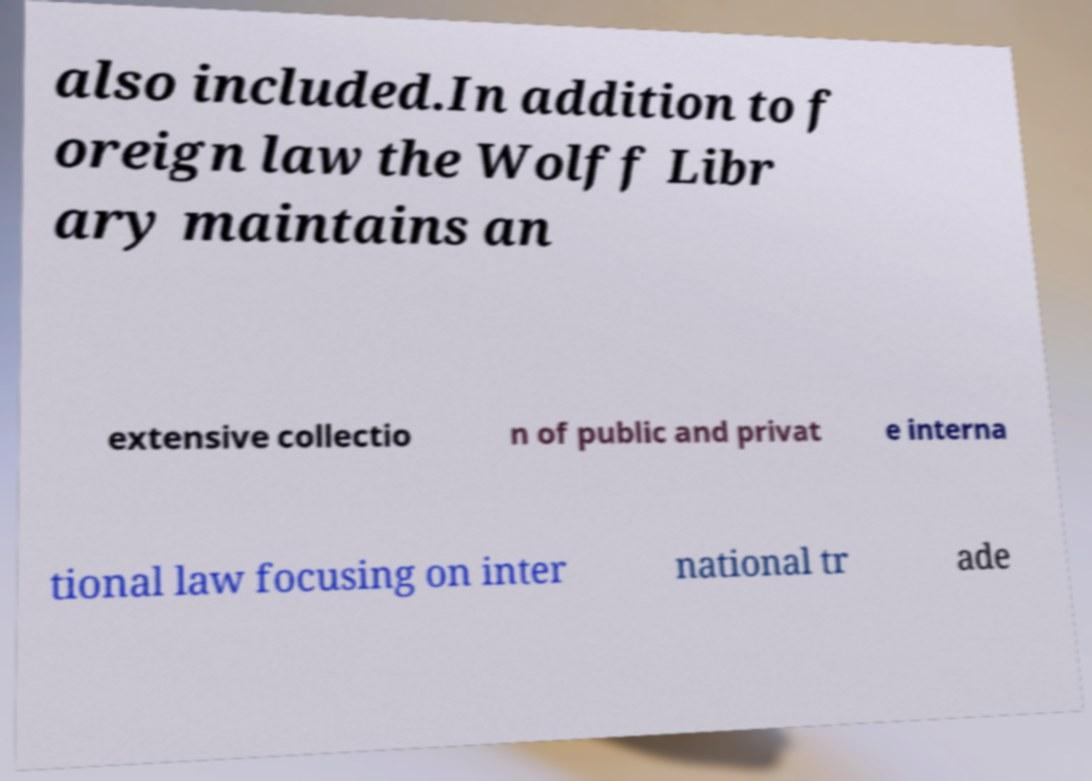Could you extract and type out the text from this image? also included.In addition to f oreign law the Wolff Libr ary maintains an extensive collectio n of public and privat e interna tional law focusing on inter national tr ade 